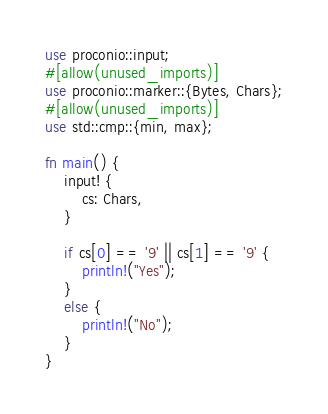Convert code to text. <code><loc_0><loc_0><loc_500><loc_500><_Rust_>use proconio::input;
#[allow(unused_imports)]
use proconio::marker::{Bytes, Chars};
#[allow(unused_imports)]
use std::cmp::{min, max};

fn main() {
	input! {
		cs: Chars,
	}

	if cs[0] == '9' || cs[1] == '9' {
		println!("Yes");
	}
	else {
		println!("No");
	}
}

</code> 